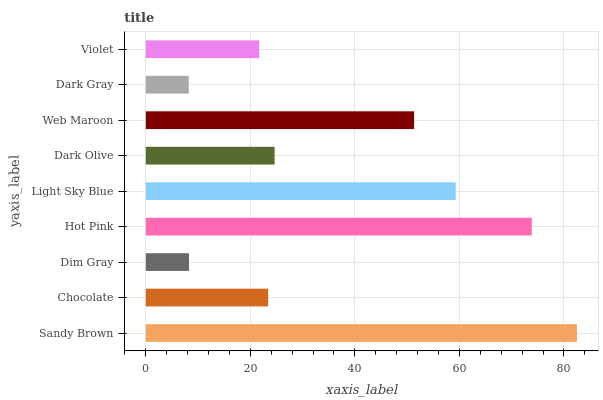Is Dark Gray the minimum?
Answer yes or no. Yes. Is Sandy Brown the maximum?
Answer yes or no. Yes. Is Chocolate the minimum?
Answer yes or no. No. Is Chocolate the maximum?
Answer yes or no. No. Is Sandy Brown greater than Chocolate?
Answer yes or no. Yes. Is Chocolate less than Sandy Brown?
Answer yes or no. Yes. Is Chocolate greater than Sandy Brown?
Answer yes or no. No. Is Sandy Brown less than Chocolate?
Answer yes or no. No. Is Dark Olive the high median?
Answer yes or no. Yes. Is Dark Olive the low median?
Answer yes or no. Yes. Is Violet the high median?
Answer yes or no. No. Is Chocolate the low median?
Answer yes or no. No. 